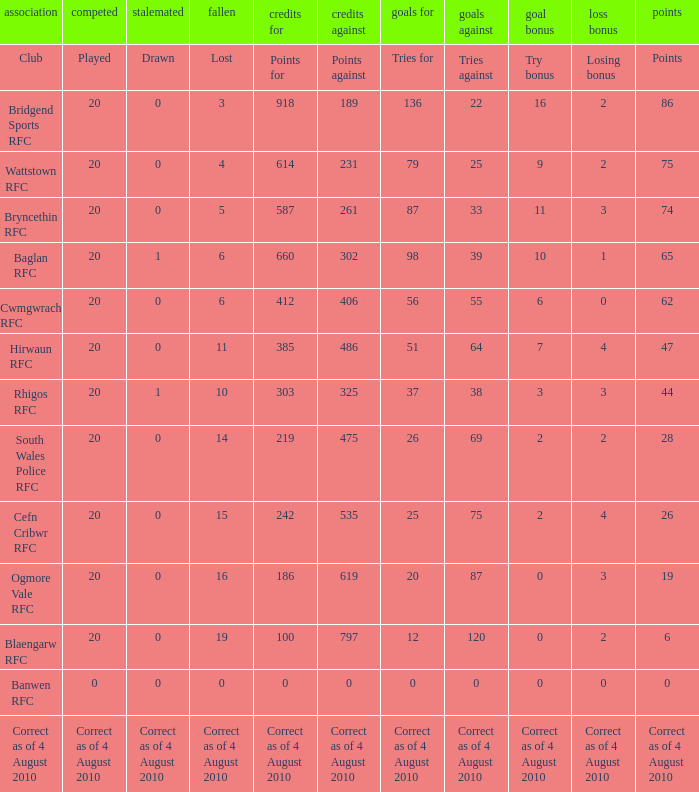What is drawn when the club is hirwaun rfc? 0.0. Can you parse all the data within this table? {'header': ['association', 'competed', 'stalemated', 'fallen', 'credits for', 'credits against', 'goals for', 'goals against', 'goal bonus', 'loss bonus', 'points'], 'rows': [['Club', 'Played', 'Drawn', 'Lost', 'Points for', 'Points against', 'Tries for', 'Tries against', 'Try bonus', 'Losing bonus', 'Points'], ['Bridgend Sports RFC', '20', '0', '3', '918', '189', '136', '22', '16', '2', '86'], ['Wattstown RFC', '20', '0', '4', '614', '231', '79', '25', '9', '2', '75'], ['Bryncethin RFC', '20', '0', '5', '587', '261', '87', '33', '11', '3', '74'], ['Baglan RFC', '20', '1', '6', '660', '302', '98', '39', '10', '1', '65'], ['Cwmgwrach RFC', '20', '0', '6', '412', '406', '56', '55', '6', '0', '62'], ['Hirwaun RFC', '20', '0', '11', '385', '486', '51', '64', '7', '4', '47'], ['Rhigos RFC', '20', '1', '10', '303', '325', '37', '38', '3', '3', '44'], ['South Wales Police RFC', '20', '0', '14', '219', '475', '26', '69', '2', '2', '28'], ['Cefn Cribwr RFC', '20', '0', '15', '242', '535', '25', '75', '2', '4', '26'], ['Ogmore Vale RFC', '20', '0', '16', '186', '619', '20', '87', '0', '3', '19'], ['Blaengarw RFC', '20', '0', '19', '100', '797', '12', '120', '0', '2', '6'], ['Banwen RFC', '0', '0', '0', '0', '0', '0', '0', '0', '0', '0'], ['Correct as of 4 August 2010', 'Correct as of 4 August 2010', 'Correct as of 4 August 2010', 'Correct as of 4 August 2010', 'Correct as of 4 August 2010', 'Correct as of 4 August 2010', 'Correct as of 4 August 2010', 'Correct as of 4 August 2010', 'Correct as of 4 August 2010', 'Correct as of 4 August 2010', 'Correct as of 4 August 2010']]} 